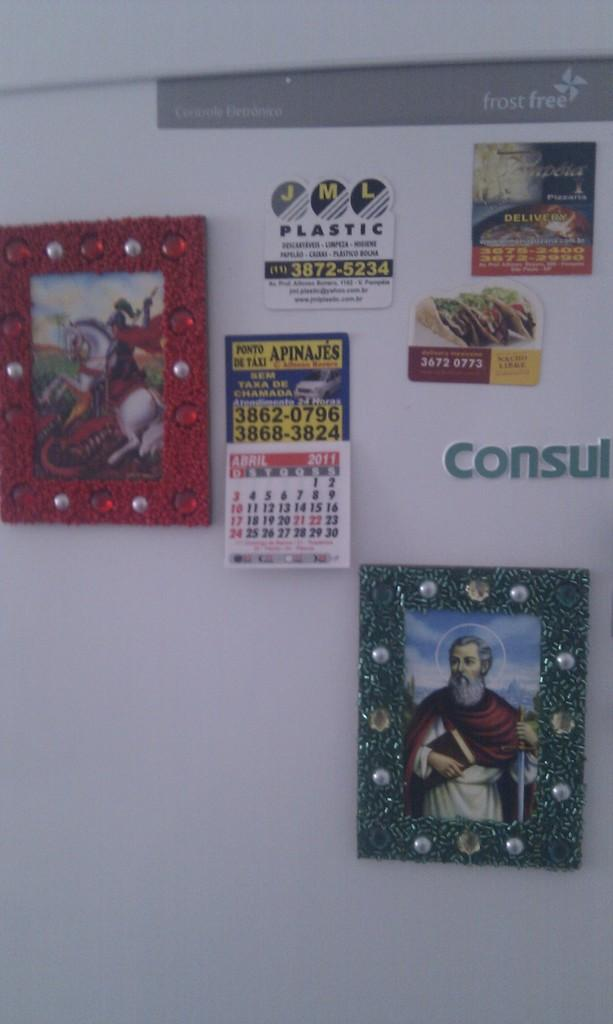Provide a one-sentence caption for the provided image. Magnets are shown on a refridgerator; one of them says JML Plastic. 